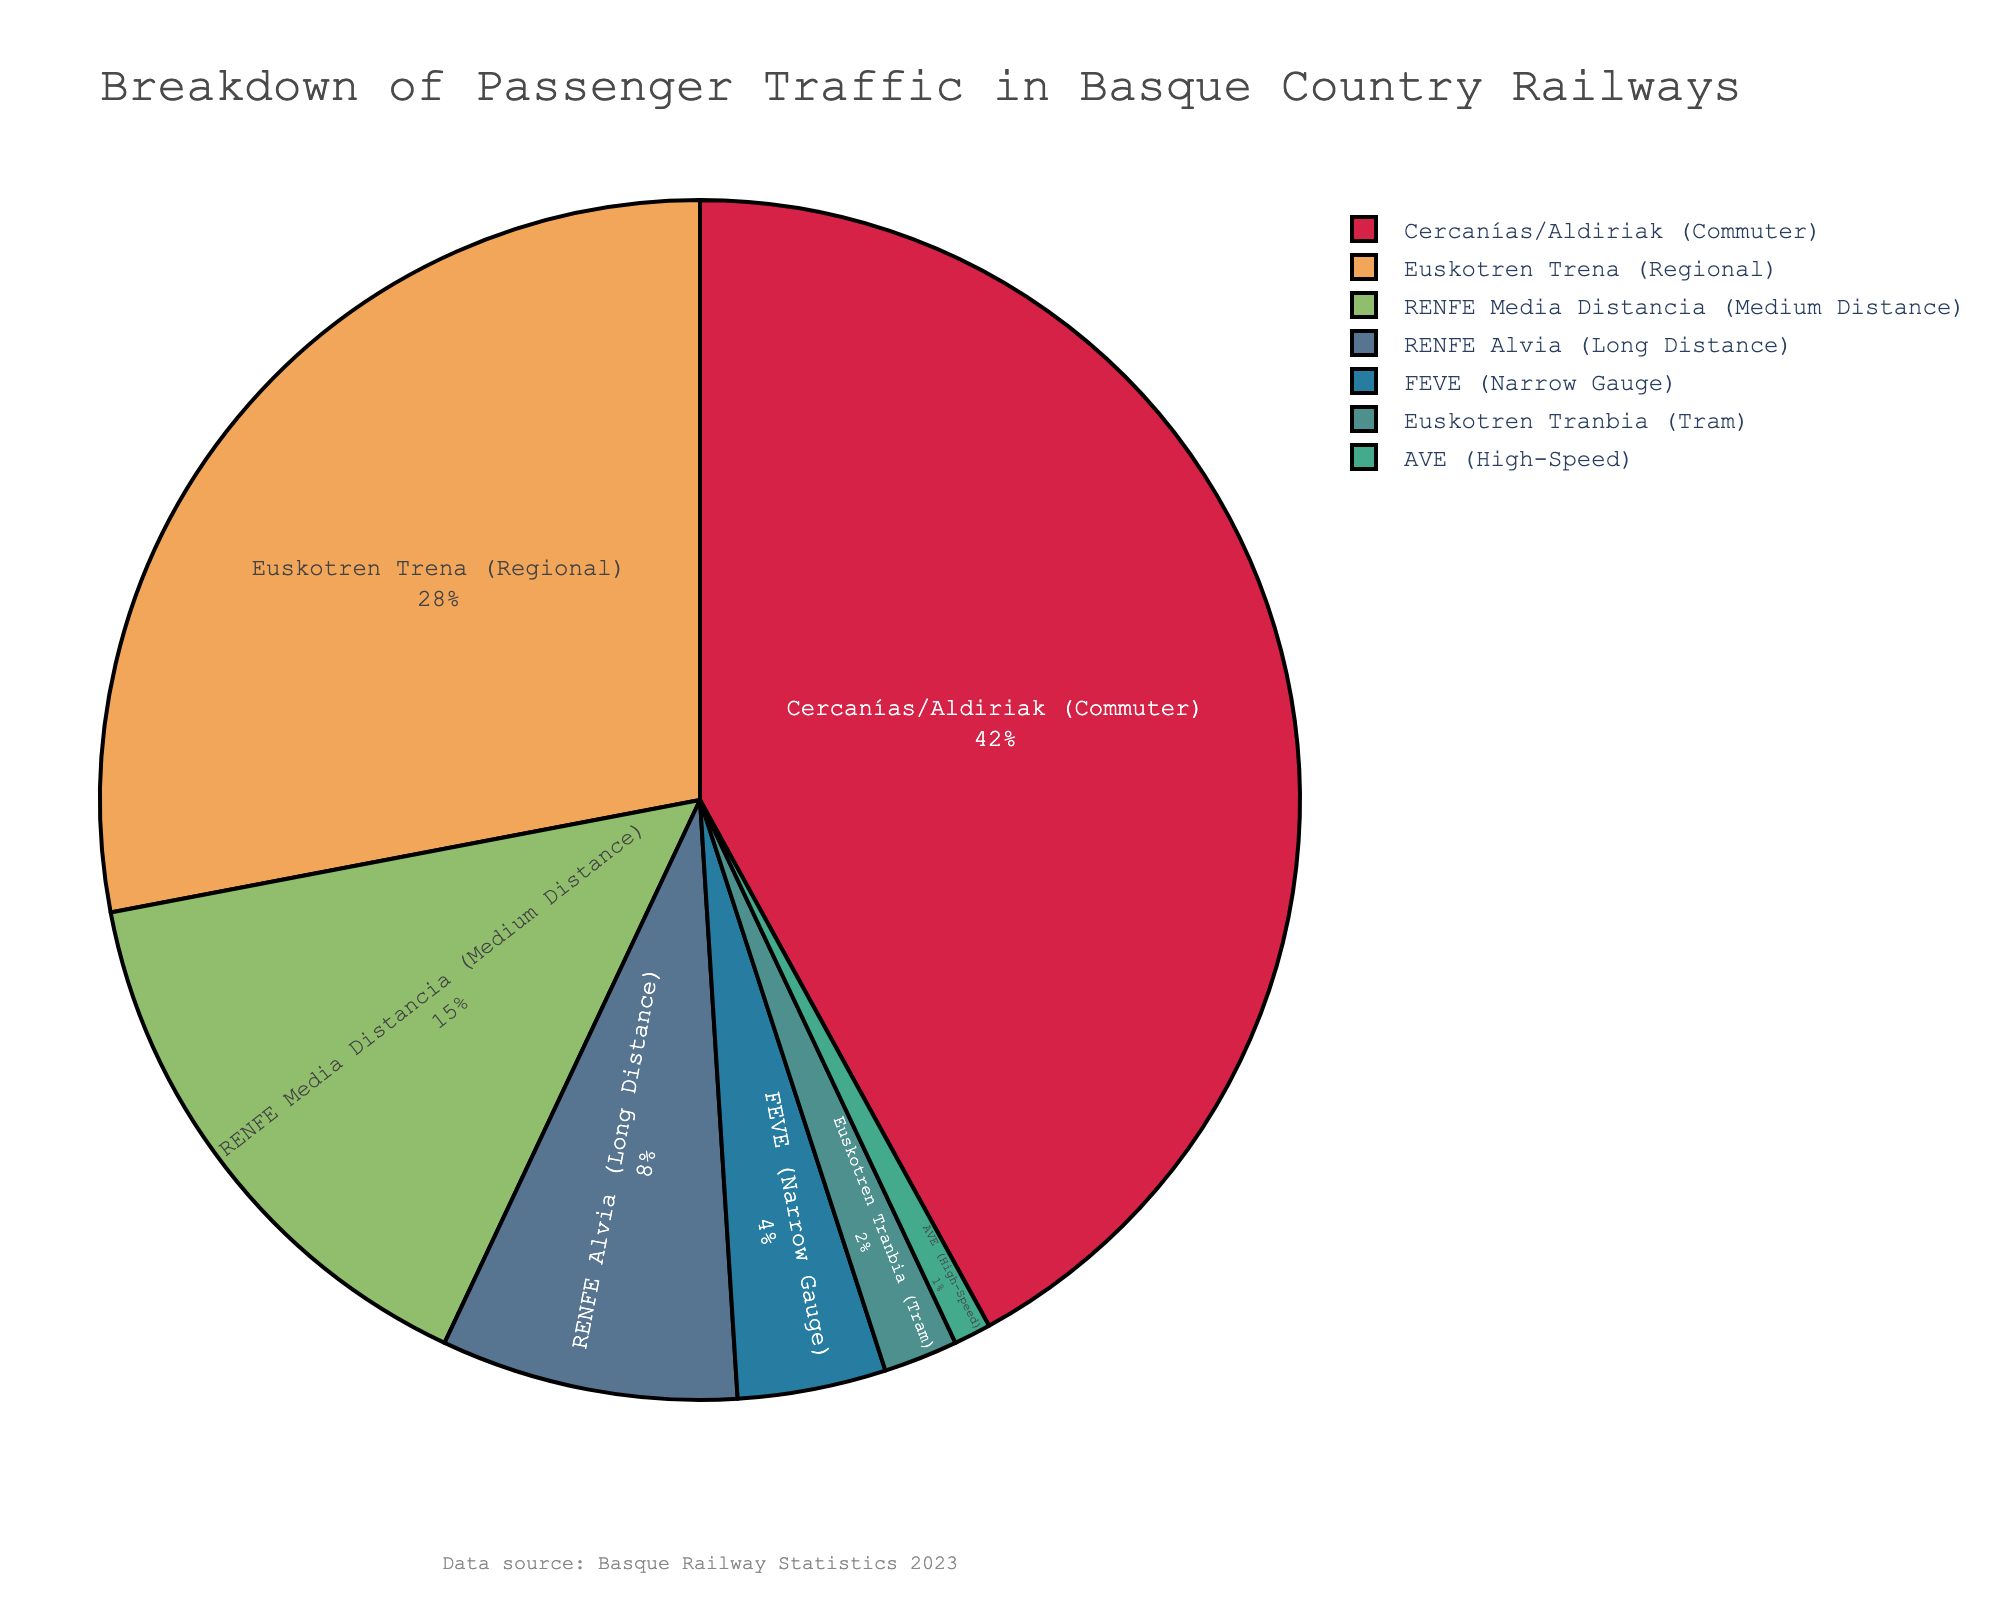What's the train service with the highest percentage of passenger traffic? The figure shows that the service with the highest percentage is represented by the largest section of the pie chart. The "Cercanías/Aldiriak (Commuter)" service occupies the largest section with 42% of the total passenger traffic.
Answer: Cercanías/Aldiriak (Commuter) What is the combined percentage of passenger traffic for Euskotren Trena and RENFE Media Distancia? To find the combined percentage, add the percentages for Euskotren Trena and RENFE Media Distancia. Euskotren Trena has 28% and RENFE Media Distancia has 15%, so the combined percentage is 28% + 15% = 43%.
Answer: 43% Which train service has the smallest percentage of passenger traffic? The smallest section of the pie chart represents the train service with the smallest percentage. The "AVE (High-Speed)" service is the smallest section with only 1% of passenger traffic.
Answer: AVE (High-Speed) How many train services have a percentage of passenger traffic greater than 10%? Identify the sections of the pie chart with percentages greater than 10%. Cercanías/Aldiriak (42%), Euskotren Trena (28%), and RENFE Media Distancia (15%) each have greater than 10%. This totals to three services.
Answer: 3 What is the difference in passenger traffic percentage between the largest and the smallest services? Subtract the smallest percentage from the largest. The largest is Cercanías/Aldiriak with 42% and the smallest is AVE with 1%. The difference is 42% - 1% = 41%.
Answer: 41% Among RENFE services (Media Distancia and Alvia), which has a larger passenger traffic percentage, and by how much? Compare the percentages of RENFE Media Distancia (15%) and RENFE Alvia (8%). RENFE Media Distancia has a larger percentage. The difference is 15% - 8% = 7%.
Answer: RENFE Media Distancia by 7% What train services together make up half of the total passenger traffic percentage? To find the services that together account for around 50%, sum up their percentages. Cercanías/Aldiriak = 42% and Euskotren Trena = 28%. Adding these two gives 42% + 28% = 70%. Since 70% is over half, check for a smaller combination: Combining Cercanías/Aldiriak (42%) and RENFE Media Distancia (15%) gives 42% + 15% = 57%. Finally, combining Euskotren Trena (28%), RENFE Media Distancia (15%), and RENFE Alvia (8%) together gives 28% + 15% + 8% = 51%.
Answer: Cercanías/Aldiriak and RENFE Media Distancia What is the average percentage of passenger traffic for all train services? Sum all percentages and divide by the number of services. (42 + 28 + 15 + 8 + 4 + 2 + 1) = 100%. There are seven services. The average is 100% / 7 ≈ 14.29%.
Answer: 14.29% Which train service is represented by a blue color in the pie chart? Observe the blue section of the pie chart. Euskotren Trena is represented by a blue color.
Answer: Euskotren Trena 